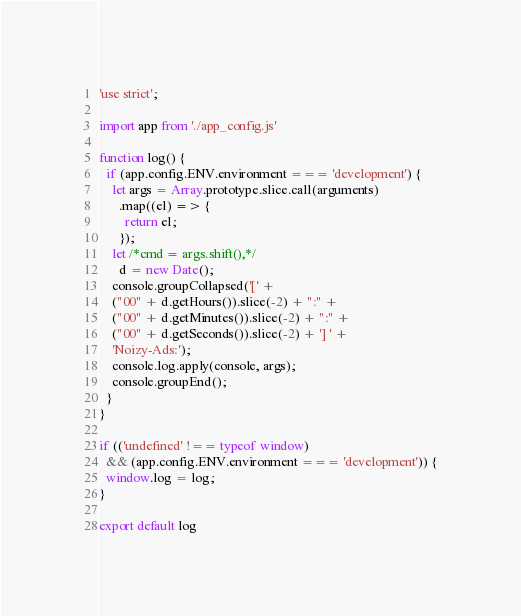Convert code to text. <code><loc_0><loc_0><loc_500><loc_500><_JavaScript_>'use strict';

import app from './app_config.js'

function log() {
  if (app.config.ENV.environment === 'development') {
    let args = Array.prototype.slice.call(arguments)
      .map((el) => {
        return el;
      });
    let /*cmd = args.shift(),*/
      d = new Date();
    console.groupCollapsed('[' +
    ("00" + d.getHours()).slice(-2) + ":" +
    ("00" + d.getMinutes()).slice(-2) + ":" +
    ("00" + d.getSeconds()).slice(-2) + '] ' +
    'Noizy-Ads:');
    console.log.apply(console, args);
    console.groupEnd();
  }
}

if (('undefined' !== typeof window)
  && (app.config.ENV.environment === 'development')) {
  window.log = log;
}

export default log
</code> 